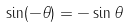<formula> <loc_0><loc_0><loc_500><loc_500>\sin ( - \theta ) = - \sin \theta</formula> 